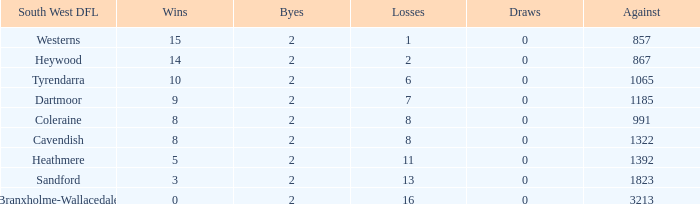Which draws have an average of 14 wins? 0.0. 